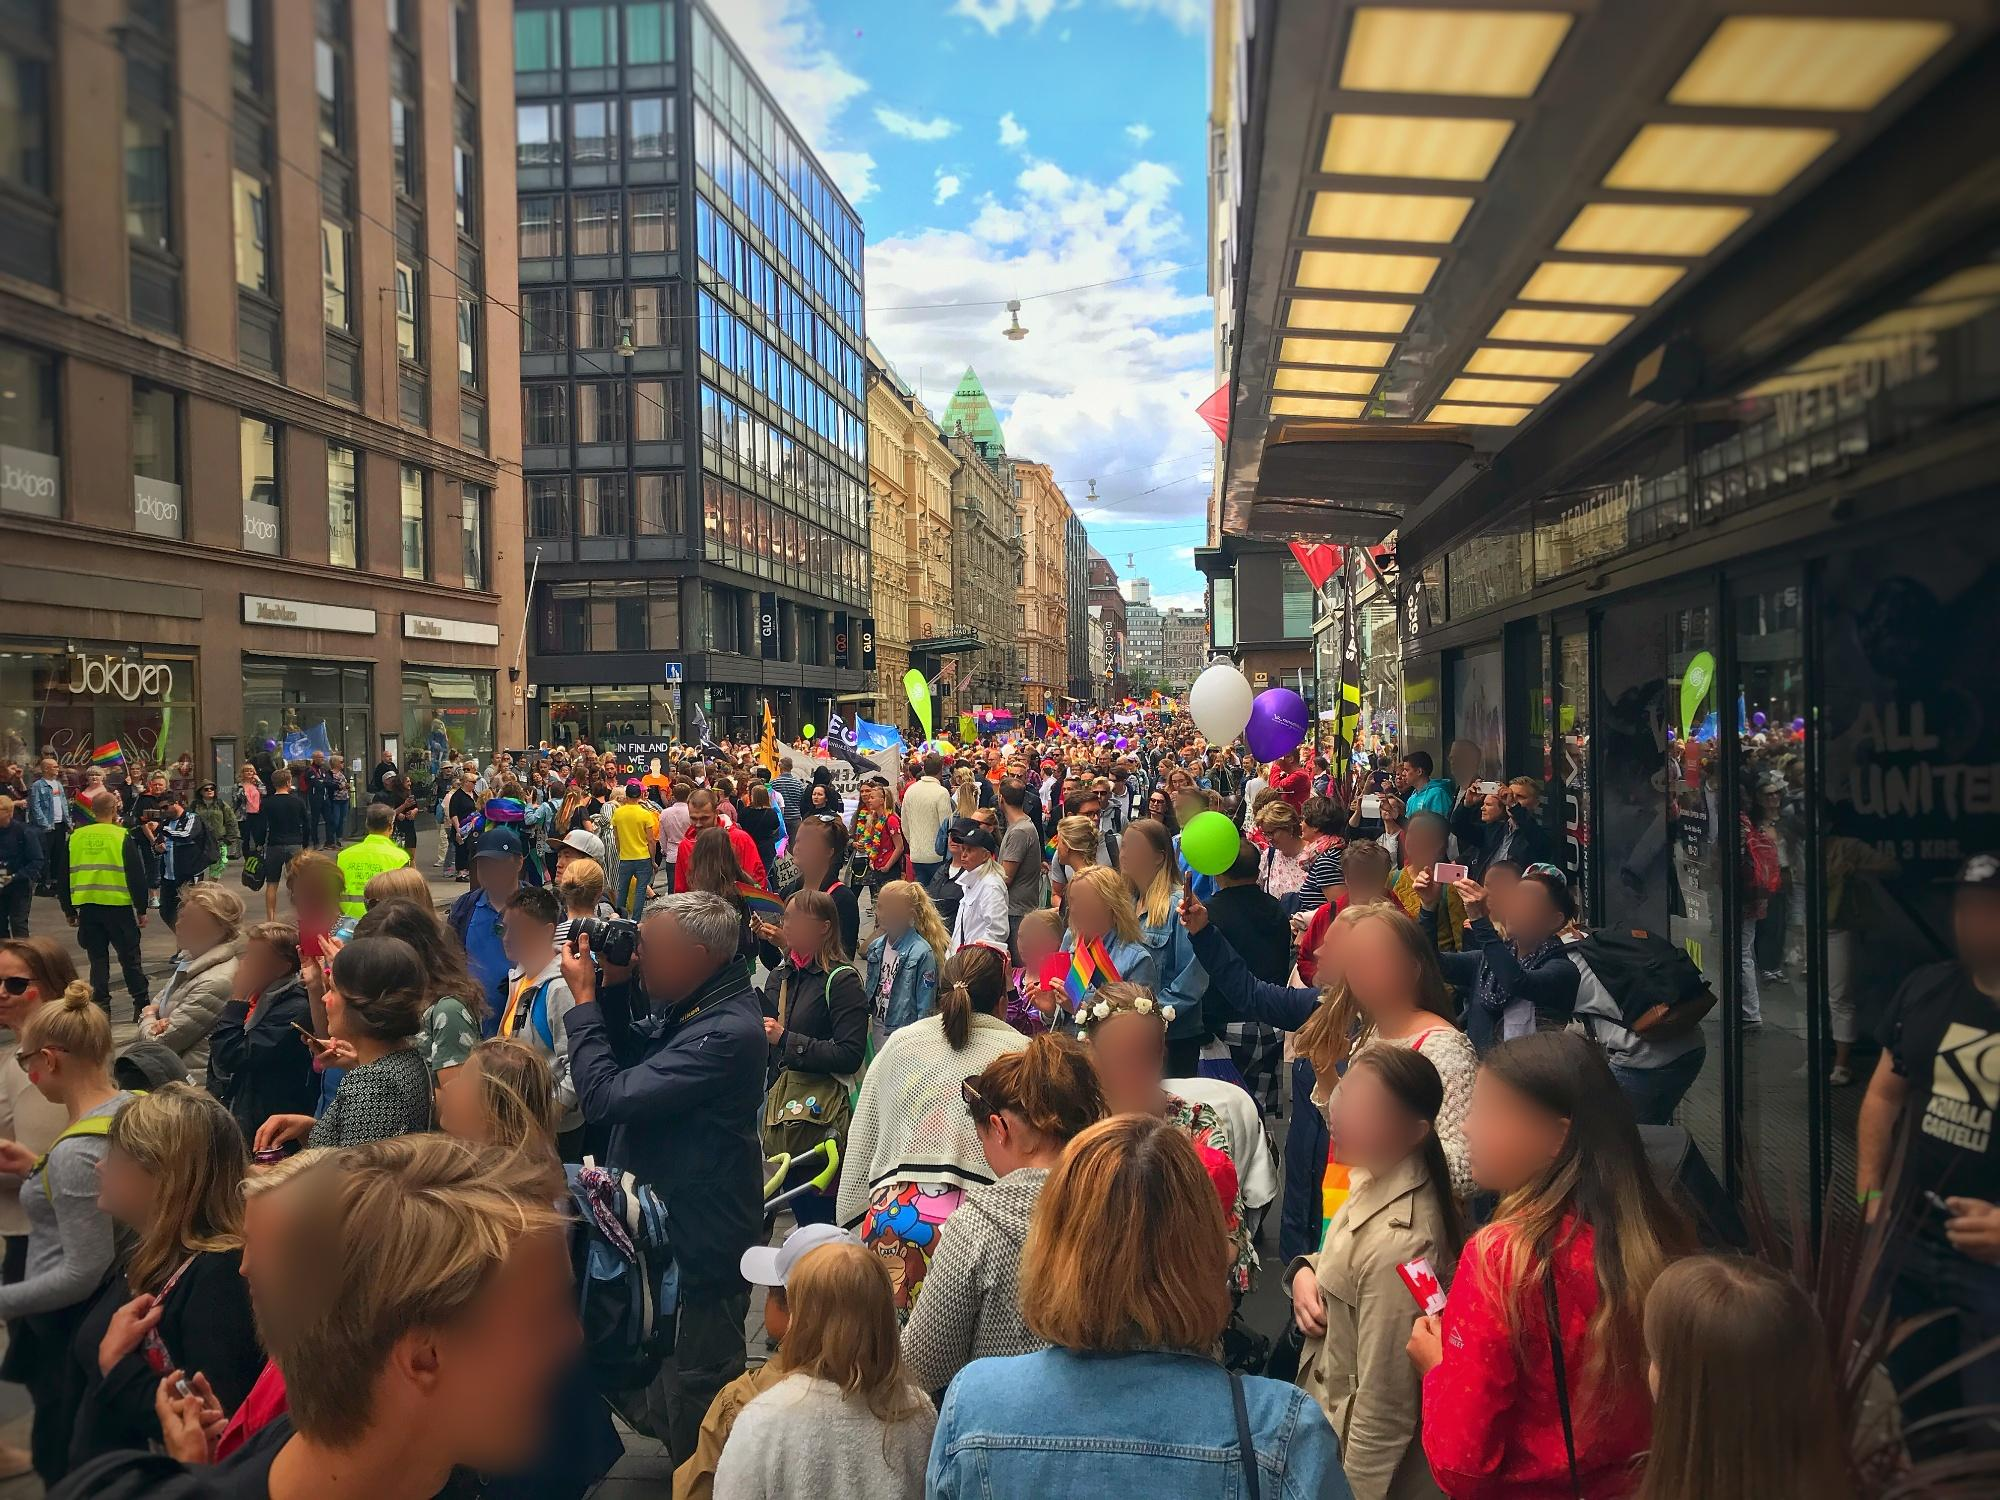Given the image, how might the parade impact local businesses? The parade is likely to have a positive impact on local businesses. The influx of people increases foot traffic significantly, leading to more potential customers visiting shops, cafes, and restaurants along the street. Business owners might see a rise in sales, especially for items related to the parade, such as refreshments, souvenirs, and festive decorations. The vibrant, festive atmosphere also serves as free advertising for the area, potentially attracting future customers who enjoyed their experience during the event.  What role might the police play in an event like this? In such a large public event, the police play a crucial role in ensuring the safety and security of all participants. They manage crowd control, direct traffic, and are vigilant for any potential disturbances. Their presence helps maintain order, prevents accidents, and provides a sense of security for those attending the parade. Additionally, they might assist in coordinating with event organizers to address any logistical issues and ensure the smooth progression of the parade. 